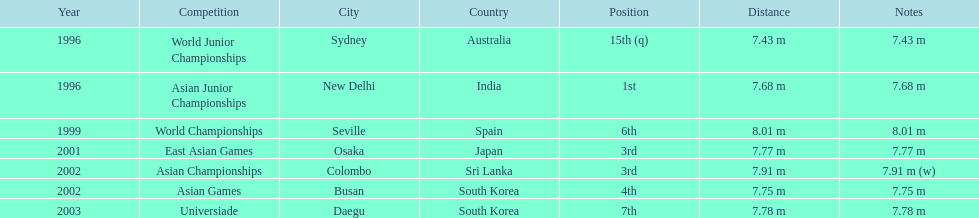Which year was his best jump? 1999. 